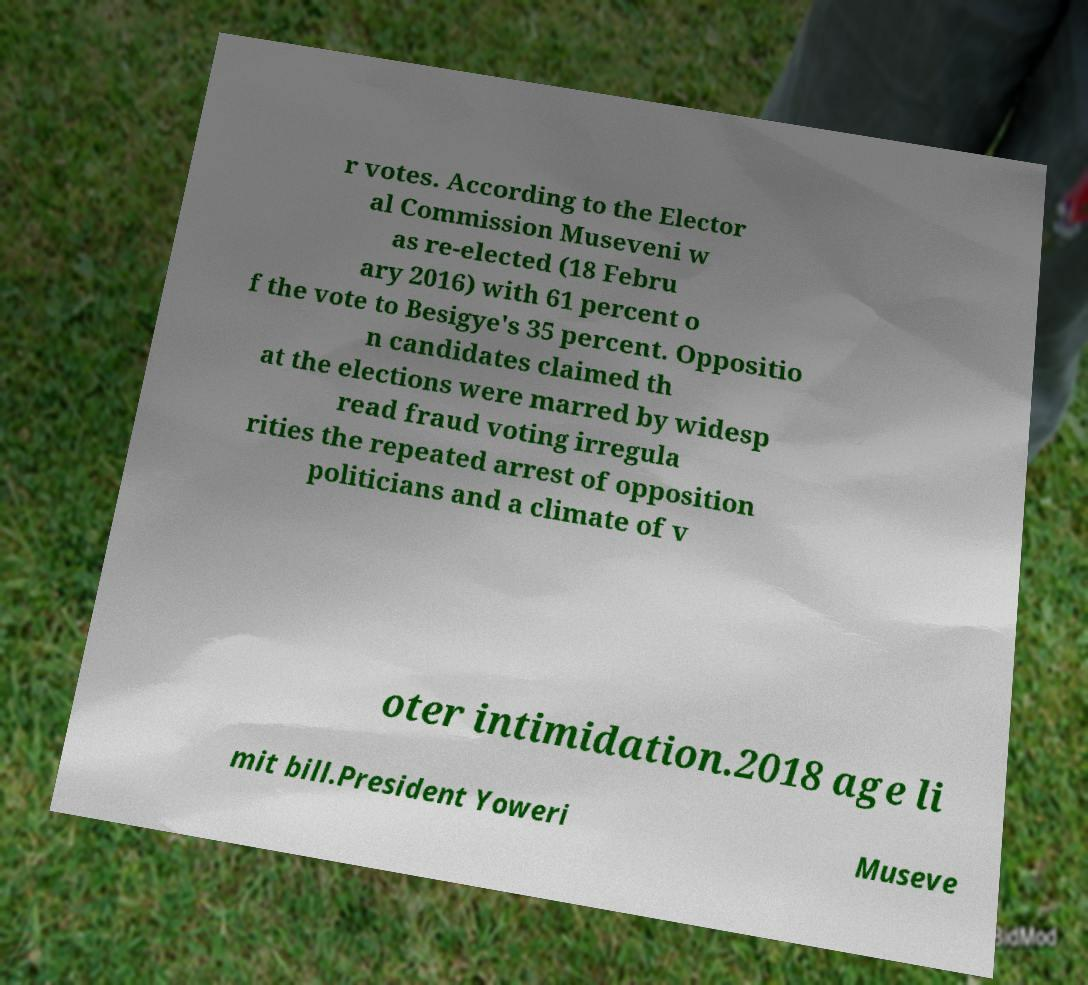There's text embedded in this image that I need extracted. Can you transcribe it verbatim? r votes. According to the Elector al Commission Museveni w as re-elected (18 Febru ary 2016) with 61 percent o f the vote to Besigye's 35 percent. Oppositio n candidates claimed th at the elections were marred by widesp read fraud voting irregula rities the repeated arrest of opposition politicians and a climate of v oter intimidation.2018 age li mit bill.President Yoweri Museve 